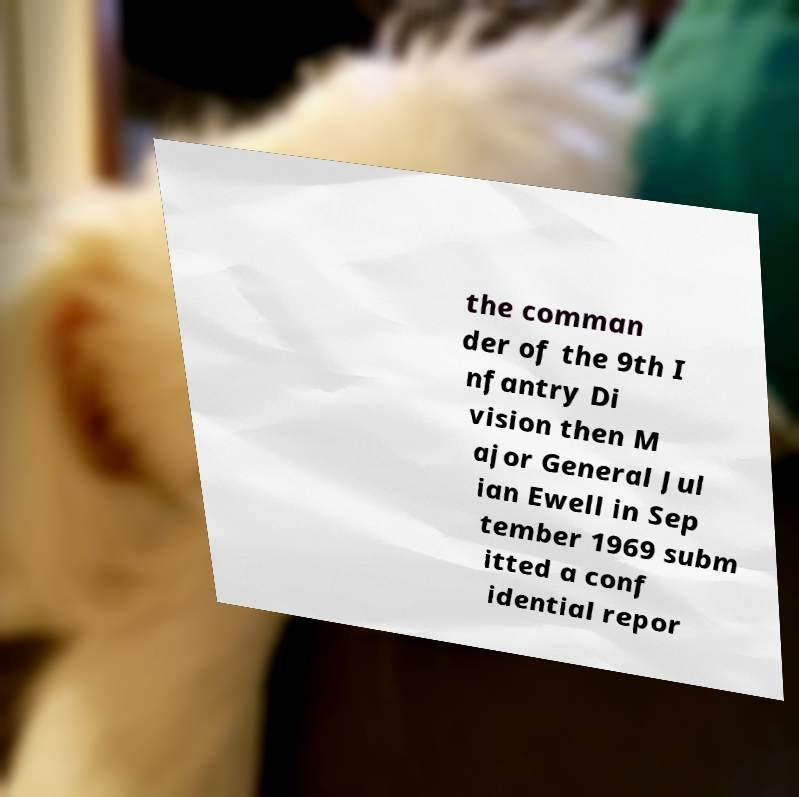Can you accurately transcribe the text from the provided image for me? the comman der of the 9th I nfantry Di vision then M ajor General Jul ian Ewell in Sep tember 1969 subm itted a conf idential repor 